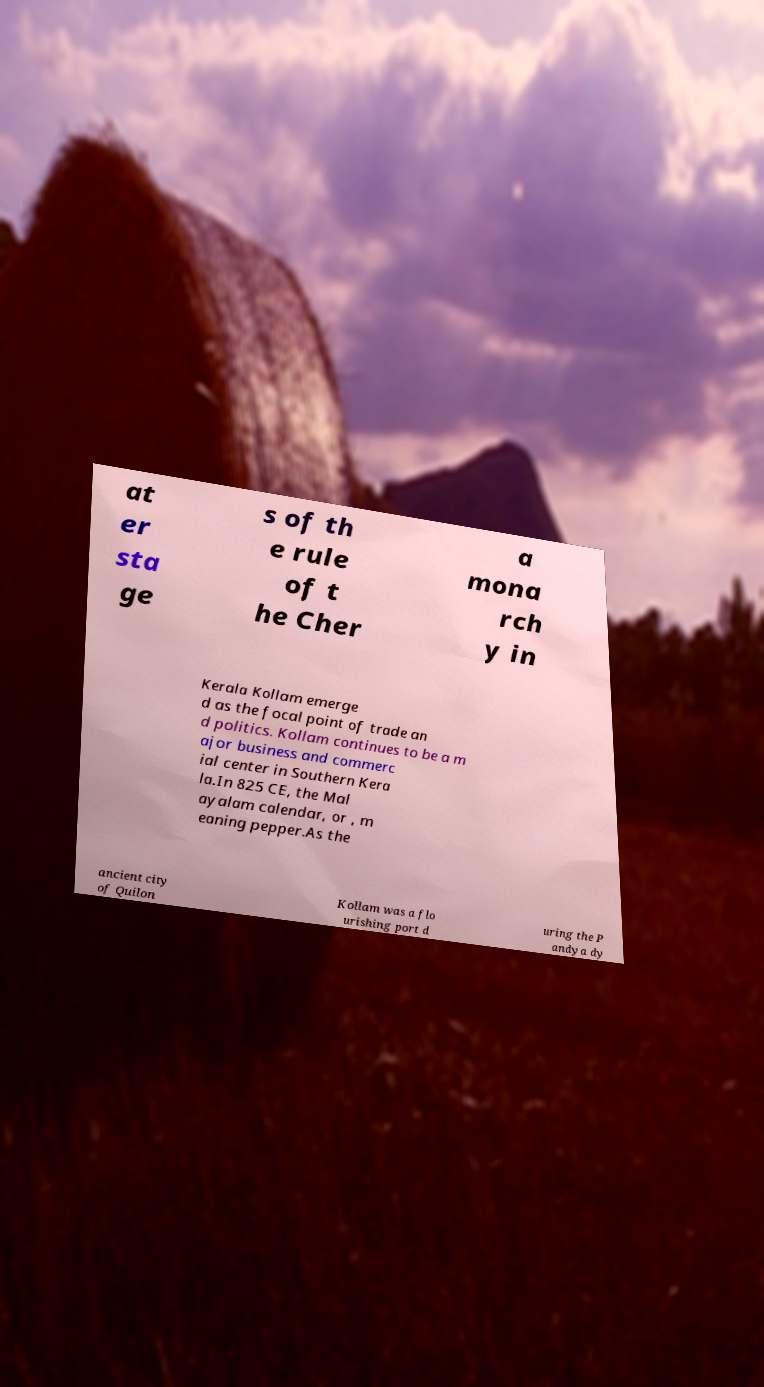Please read and relay the text visible in this image. What does it say? at er sta ge s of th e rule of t he Cher a mona rch y in Kerala Kollam emerge d as the focal point of trade an d politics. Kollam continues to be a m ajor business and commerc ial center in Southern Kera la.In 825 CE, the Mal ayalam calendar, or , m eaning pepper.As the ancient city of Quilon Kollam was a flo urishing port d uring the P andya dy 